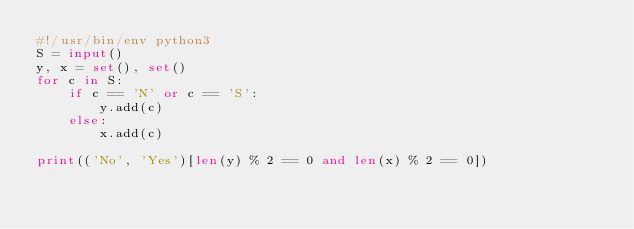<code> <loc_0><loc_0><loc_500><loc_500><_Python_>#!/usr/bin/env python3
S = input()
y, x = set(), set()
for c in S:
    if c == 'N' or c == 'S':
        y.add(c)
    else:
        x.add(c)

print(('No', 'Yes')[len(y) % 2 == 0 and len(x) % 2 == 0])
</code> 